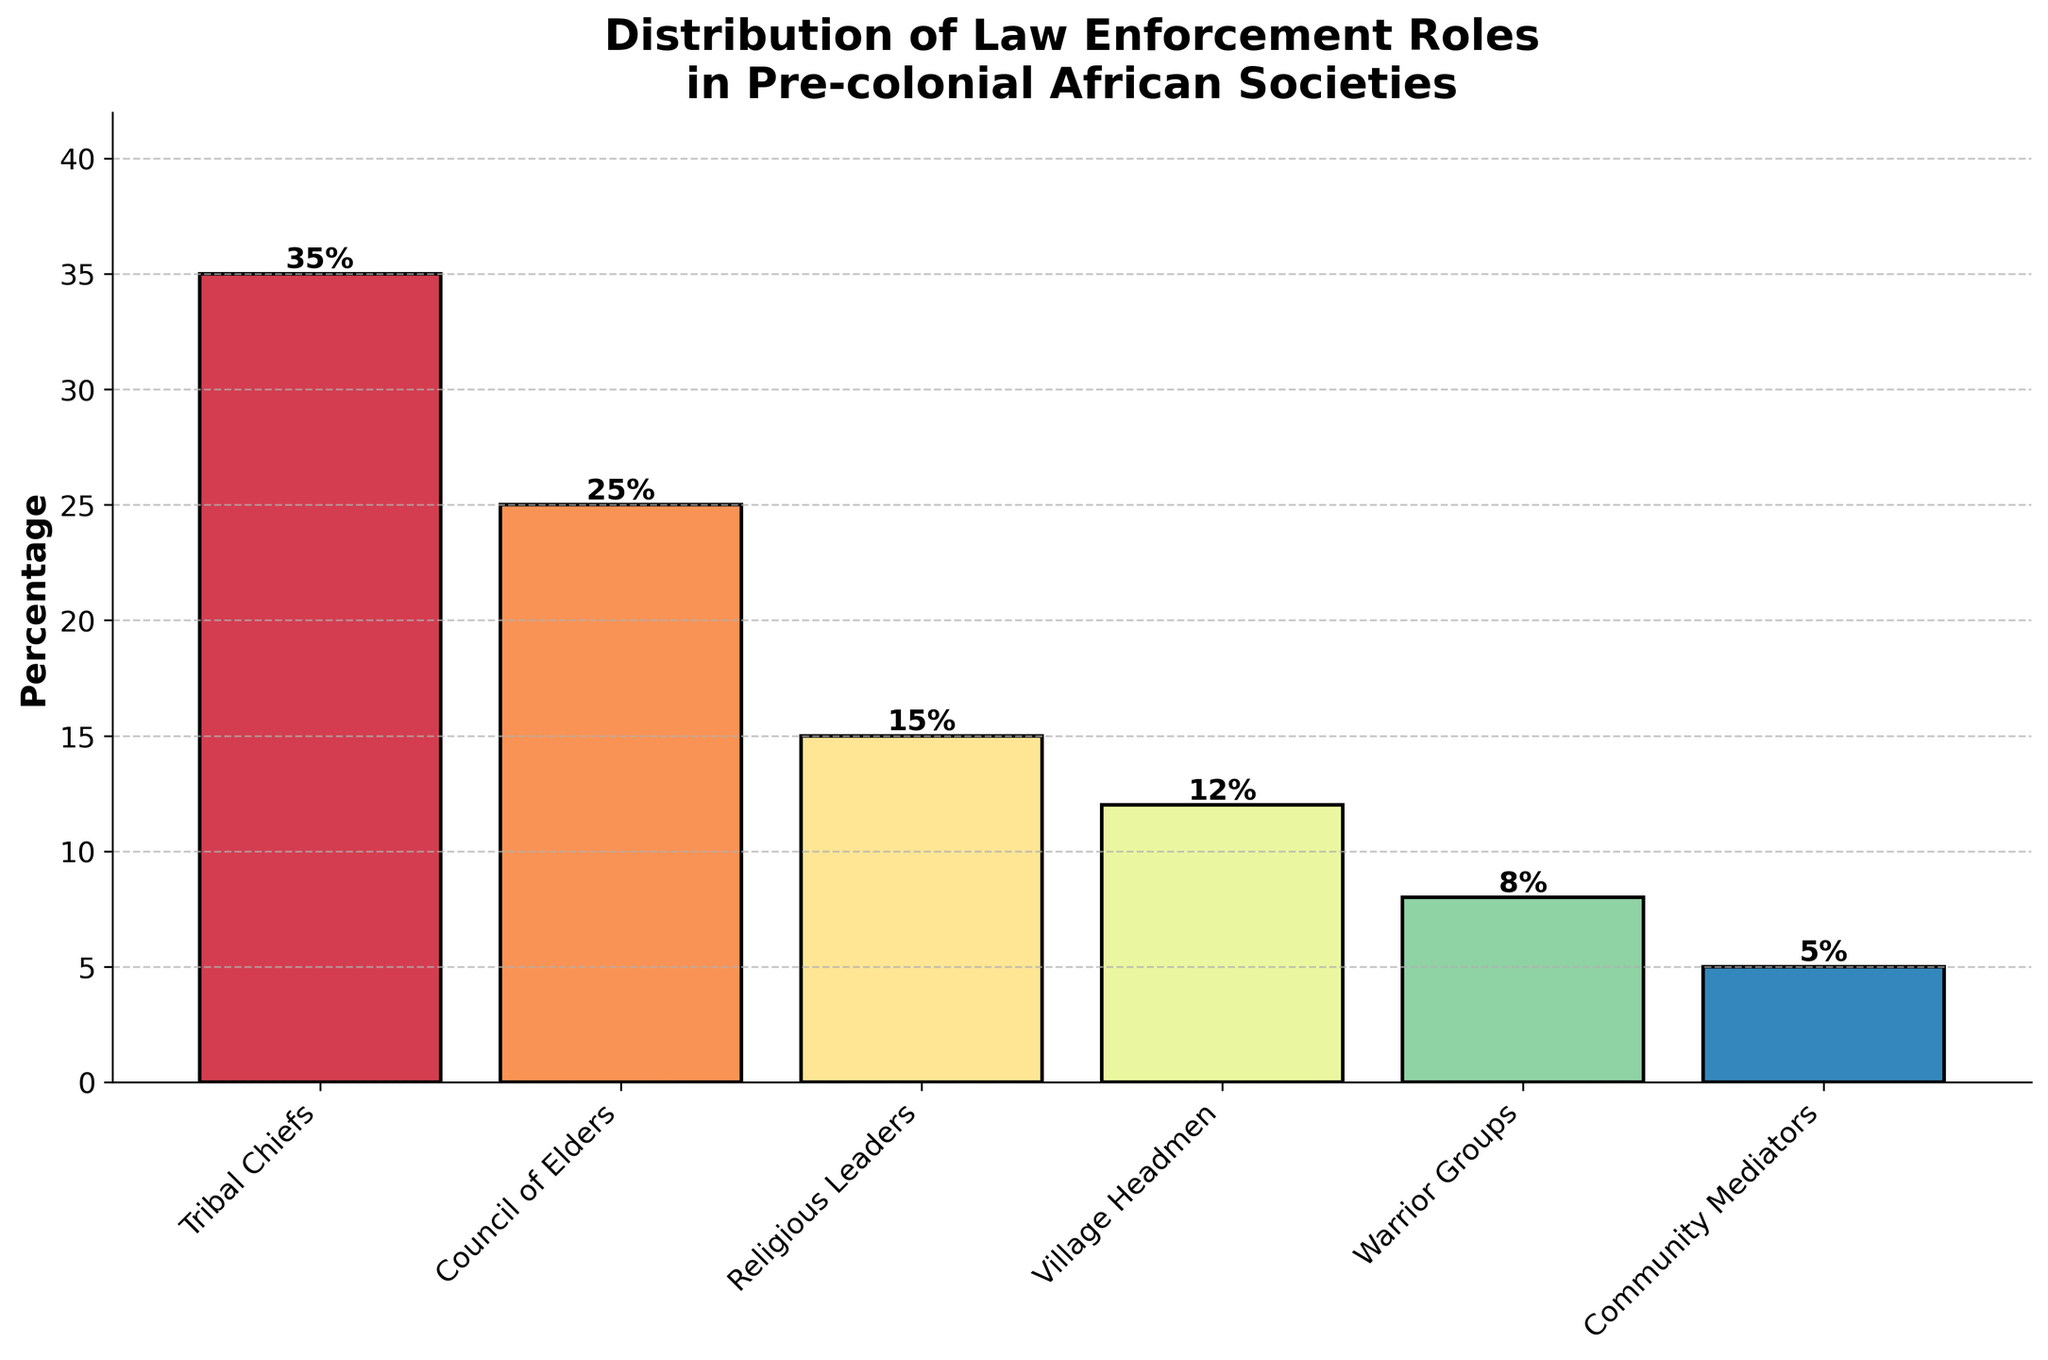Which role has the highest percentage in law enforcement in pre-colonial African societies? The highest percentage is indicated by the tallest bar in the chart. The bar for Tribal Chiefs is the tallest, representing 35%.
Answer: Tribal Chiefs What is the combined percentage of law enforcement roles attributed to Community Mediators and Warrior Groups? Add the percentages for Community Mediators and Warrior Groups. The percentages are 5% (Community Mediators) and 8% (Warrior Groups). Therefore, 5 + 8 = 13%.
Answer: 13% Which role is represented by the second tallest bar, and what is its percentage? The second tallest bar corresponds to the Council of Elders, which is represented with a percentage value of 25%.
Answer: Council of Elders, 25% How does the percentage of Village Headmen compare to the percentage of Religious Leaders? Compare the heights of the bars. The percentage for Village Headmen is 12%, while the percentage for Religious Leaders is 15%. Thus, Village Headmen have a lower percentage compared to Religious Leaders.
Answer: Lower What is the difference in percentage between the role with the highest and lowest representation? Subtract the smallest percentage from the largest. The highest percentage is 35% for Tribal Chiefs, and the lowest is 5% for Community Mediators. Therefore, 35 - 5 = 30%.
Answer: 30% What roles together make up half of the law enforcement distribution? Identify roles whose combined percentages add up to 50%. Tribal Chiefs (35%) and Council of Elders (25%) together sum up to 35 + 25 = 60%, which is slightly above 50%, so another combination needed. Combining fewer roles like Religious Leaders (15%), Village Headmen (12%), Warrior Groups (8%), and Community Mediators (5%) also doesn't equal exactly 50%, so 60% with the first combination fits best close to 'half'.
Answer: Tribal Chiefs and Council of Elders If you were to combine the percentages of the three least represented roles, what would be the result? Add the percentages of Village Headmen, Warrior Groups, and Community Mediators. The percentages are 12% (Village Headmen), 8% (Warrior Groups), and 5% (Community Mediators). Thus, 12 + 8 + 5 = 25%.
Answer: 25% Which roles have a combined percentage that is less than the percentage of Council of Elders? Identify roles whose cumulative percentage is less than 25%. The percentages for Warrior Groups (8%) and Community Mediators (5%) together sum up to 13%, which is less than 25%.
Answer: Warrior Groups and Community Mediators 